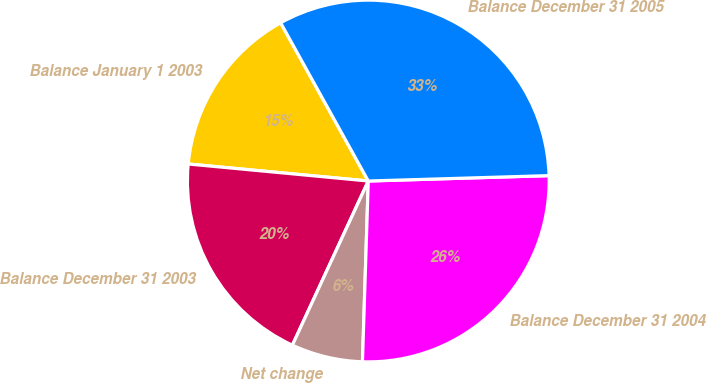Convert chart to OTSL. <chart><loc_0><loc_0><loc_500><loc_500><pie_chart><fcel>Balance January 1 2003<fcel>Balance December 31 2003<fcel>Net change<fcel>Balance December 31 2004<fcel>Balance December 31 2005<nl><fcel>15.45%<fcel>19.61%<fcel>6.38%<fcel>25.99%<fcel>32.58%<nl></chart> 